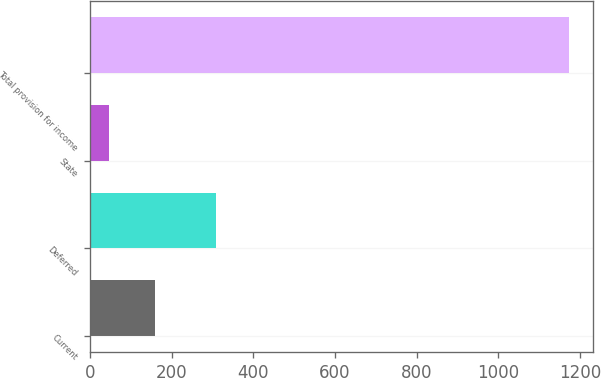Convert chart. <chart><loc_0><loc_0><loc_500><loc_500><bar_chart><fcel>Current<fcel>Deferred<fcel>State<fcel>Total provision for income<nl><fcel>158.7<fcel>309<fcel>46<fcel>1173<nl></chart> 